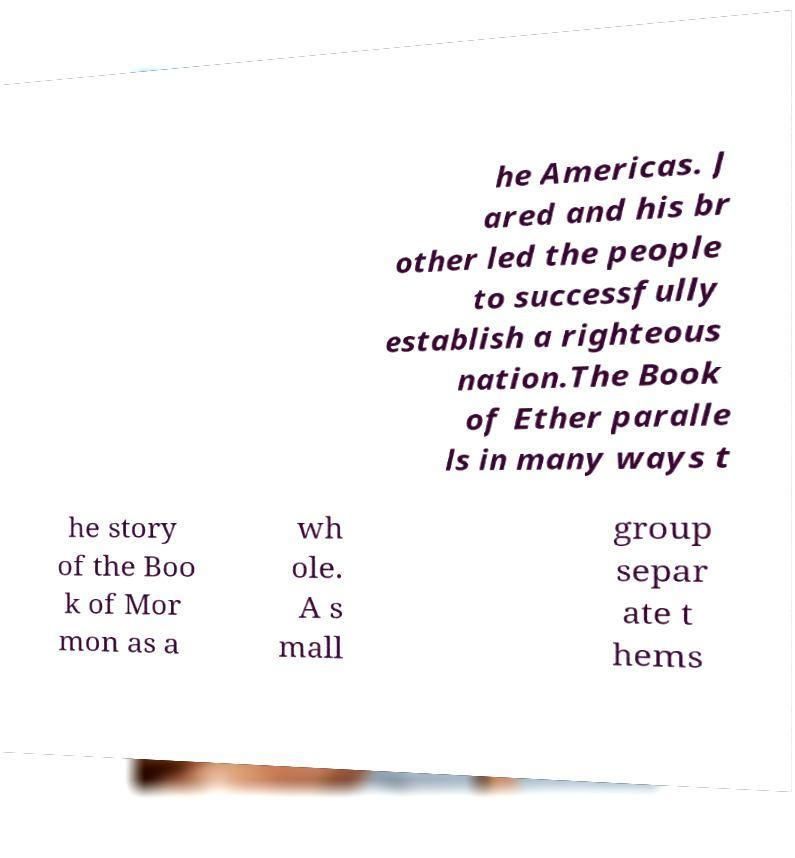Please identify and transcribe the text found in this image. he Americas. J ared and his br other led the people to successfully establish a righteous nation.The Book of Ether paralle ls in many ways t he story of the Boo k of Mor mon as a wh ole. A s mall group separ ate t hems 